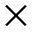Convert formula to latex. <formula><loc_0><loc_0><loc_500><loc_500>\times</formula> 